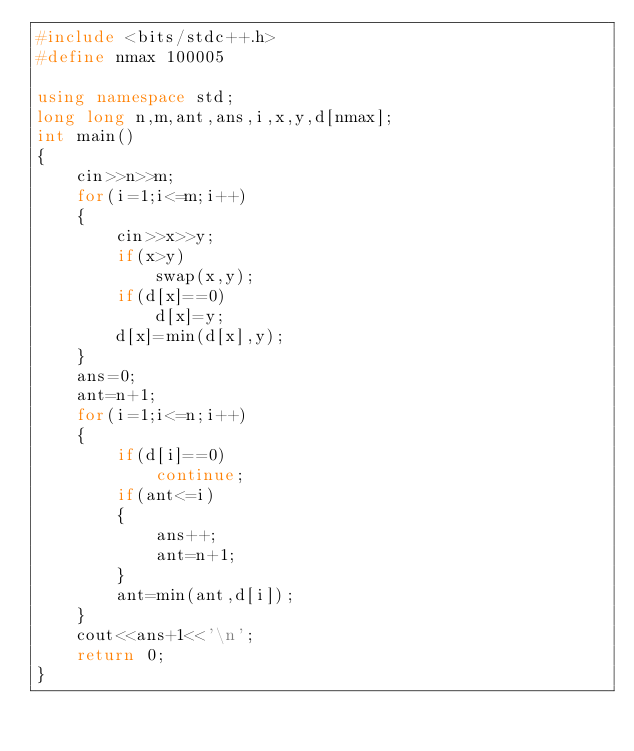Convert code to text. <code><loc_0><loc_0><loc_500><loc_500><_C++_>#include <bits/stdc++.h>
#define nmax 100005

using namespace std;
long long n,m,ant,ans,i,x,y,d[nmax];
int main()
{
    cin>>n>>m;
    for(i=1;i<=m;i++)
    {
        cin>>x>>y;
        if(x>y)
            swap(x,y);
        if(d[x]==0)
            d[x]=y;
        d[x]=min(d[x],y);
    }
    ans=0;
    ant=n+1;
    for(i=1;i<=n;i++)
    {
        if(d[i]==0)
            continue;
        if(ant<=i)
        {
            ans++;
            ant=n+1;
        }
        ant=min(ant,d[i]);
    }
    cout<<ans+1<<'\n';
    return 0;
}
</code> 